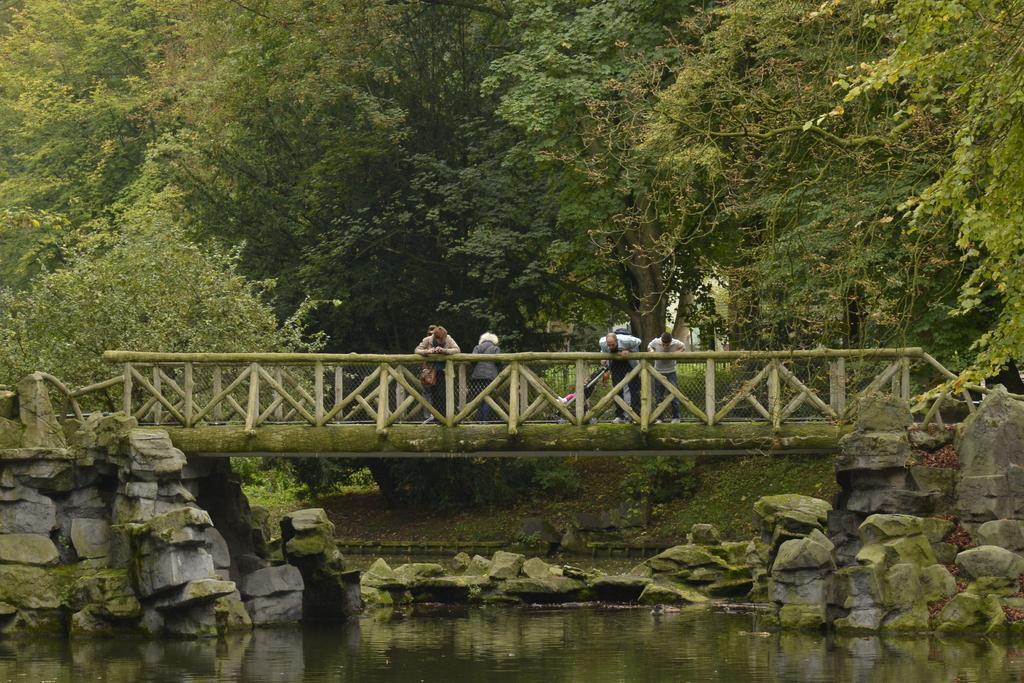Can you describe this image briefly? In this image we can see water and rocks at the bottom of the image. There is a bridge with fencing. On the bridge there are few people standing. In the background there are trees. Also there is a stroller on the bridge. 